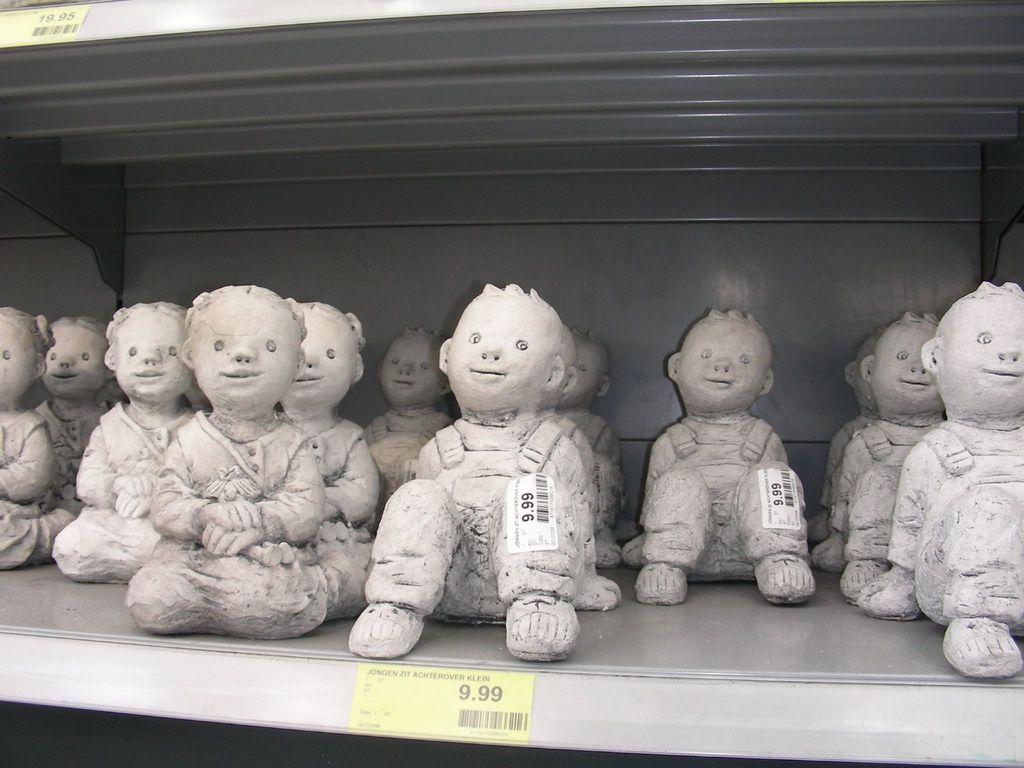What type of objects are depicted in the image? There are statues of children in the image. How are the statues arranged in the image? The statues are placed in a rack. What color are the statues? The statues are white in color. What color are the racks? The racks are grey in color. What type of fuel is being used by the statues in the image? There is no fuel being used by the statues in the image, as they are inanimate objects. 